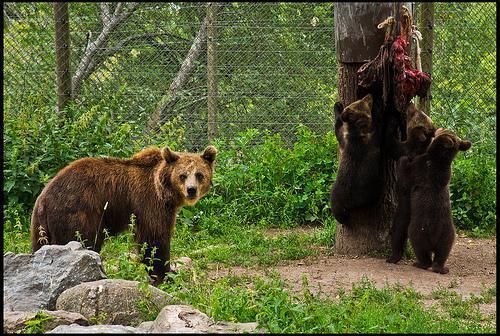How many full grown bears are in the picture?
Give a very brief answer. 1. How many bears are standing on all four paws?
Give a very brief answer. 1. 